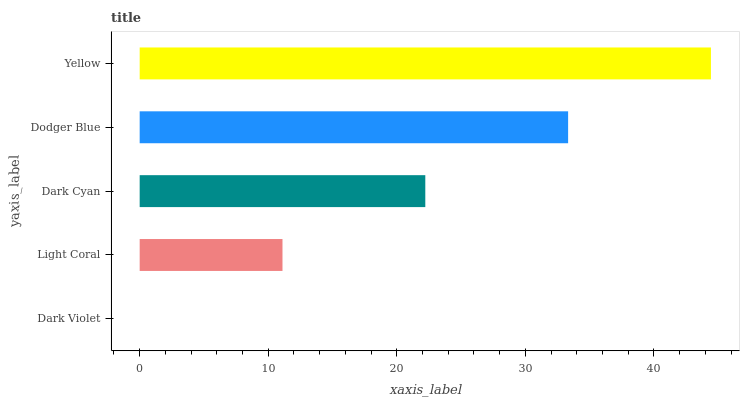Is Dark Violet the minimum?
Answer yes or no. Yes. Is Yellow the maximum?
Answer yes or no. Yes. Is Light Coral the minimum?
Answer yes or no. No. Is Light Coral the maximum?
Answer yes or no. No. Is Light Coral greater than Dark Violet?
Answer yes or no. Yes. Is Dark Violet less than Light Coral?
Answer yes or no. Yes. Is Dark Violet greater than Light Coral?
Answer yes or no. No. Is Light Coral less than Dark Violet?
Answer yes or no. No. Is Dark Cyan the high median?
Answer yes or no. Yes. Is Dark Cyan the low median?
Answer yes or no. Yes. Is Yellow the high median?
Answer yes or no. No. Is Yellow the low median?
Answer yes or no. No. 